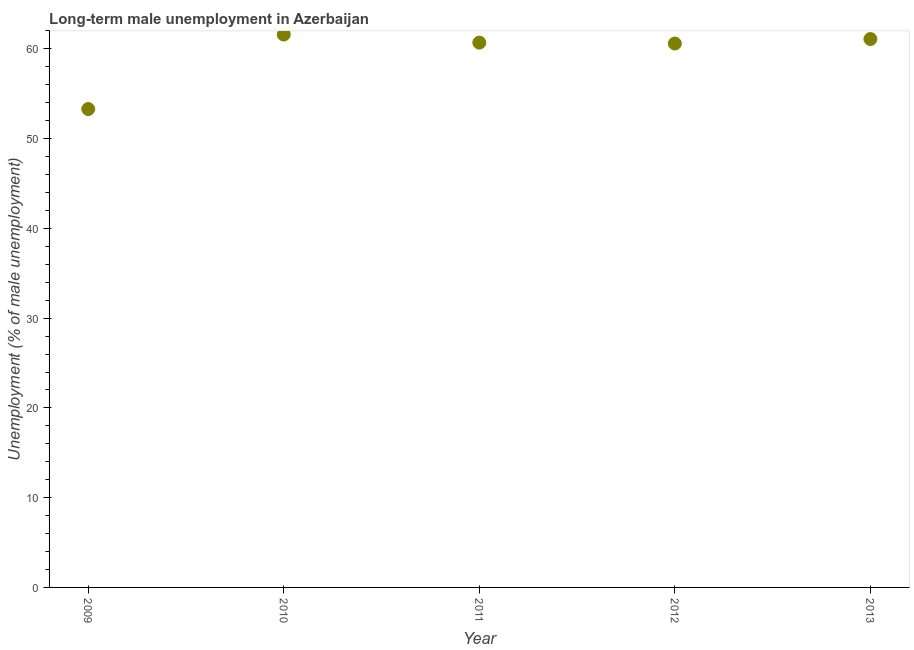What is the long-term male unemployment in 2012?
Your response must be concise. 60.6. Across all years, what is the maximum long-term male unemployment?
Provide a short and direct response. 61.6. Across all years, what is the minimum long-term male unemployment?
Offer a very short reply. 53.3. What is the sum of the long-term male unemployment?
Offer a terse response. 297.3. What is the difference between the long-term male unemployment in 2011 and 2012?
Your response must be concise. 0.1. What is the average long-term male unemployment per year?
Ensure brevity in your answer.  59.46. What is the median long-term male unemployment?
Offer a terse response. 60.7. In how many years, is the long-term male unemployment greater than 40 %?
Ensure brevity in your answer.  5. Do a majority of the years between 2010 and 2011 (inclusive) have long-term male unemployment greater than 12 %?
Make the answer very short. Yes. What is the ratio of the long-term male unemployment in 2010 to that in 2011?
Offer a very short reply. 1.01. Is the long-term male unemployment in 2009 less than that in 2012?
Ensure brevity in your answer.  Yes. Is the sum of the long-term male unemployment in 2012 and 2013 greater than the maximum long-term male unemployment across all years?
Your answer should be very brief. Yes. What is the difference between the highest and the lowest long-term male unemployment?
Provide a short and direct response. 8.3. In how many years, is the long-term male unemployment greater than the average long-term male unemployment taken over all years?
Provide a short and direct response. 4. How many dotlines are there?
Provide a succinct answer. 1. What is the difference between two consecutive major ticks on the Y-axis?
Your response must be concise. 10. Are the values on the major ticks of Y-axis written in scientific E-notation?
Provide a succinct answer. No. Does the graph contain grids?
Provide a short and direct response. No. What is the title of the graph?
Your answer should be compact. Long-term male unemployment in Azerbaijan. What is the label or title of the Y-axis?
Your answer should be very brief. Unemployment (% of male unemployment). What is the Unemployment (% of male unemployment) in 2009?
Keep it short and to the point. 53.3. What is the Unemployment (% of male unemployment) in 2010?
Provide a succinct answer. 61.6. What is the Unemployment (% of male unemployment) in 2011?
Give a very brief answer. 60.7. What is the Unemployment (% of male unemployment) in 2012?
Ensure brevity in your answer.  60.6. What is the Unemployment (% of male unemployment) in 2013?
Make the answer very short. 61.1. What is the difference between the Unemployment (% of male unemployment) in 2010 and 2011?
Ensure brevity in your answer.  0.9. What is the difference between the Unemployment (% of male unemployment) in 2010 and 2013?
Make the answer very short. 0.5. What is the difference between the Unemployment (% of male unemployment) in 2011 and 2012?
Your answer should be very brief. 0.1. What is the difference between the Unemployment (% of male unemployment) in 2011 and 2013?
Your answer should be compact. -0.4. What is the difference between the Unemployment (% of male unemployment) in 2012 and 2013?
Ensure brevity in your answer.  -0.5. What is the ratio of the Unemployment (% of male unemployment) in 2009 to that in 2010?
Provide a succinct answer. 0.86. What is the ratio of the Unemployment (% of male unemployment) in 2009 to that in 2011?
Offer a terse response. 0.88. What is the ratio of the Unemployment (% of male unemployment) in 2009 to that in 2013?
Your answer should be compact. 0.87. What is the ratio of the Unemployment (% of male unemployment) in 2010 to that in 2012?
Offer a terse response. 1.02. 